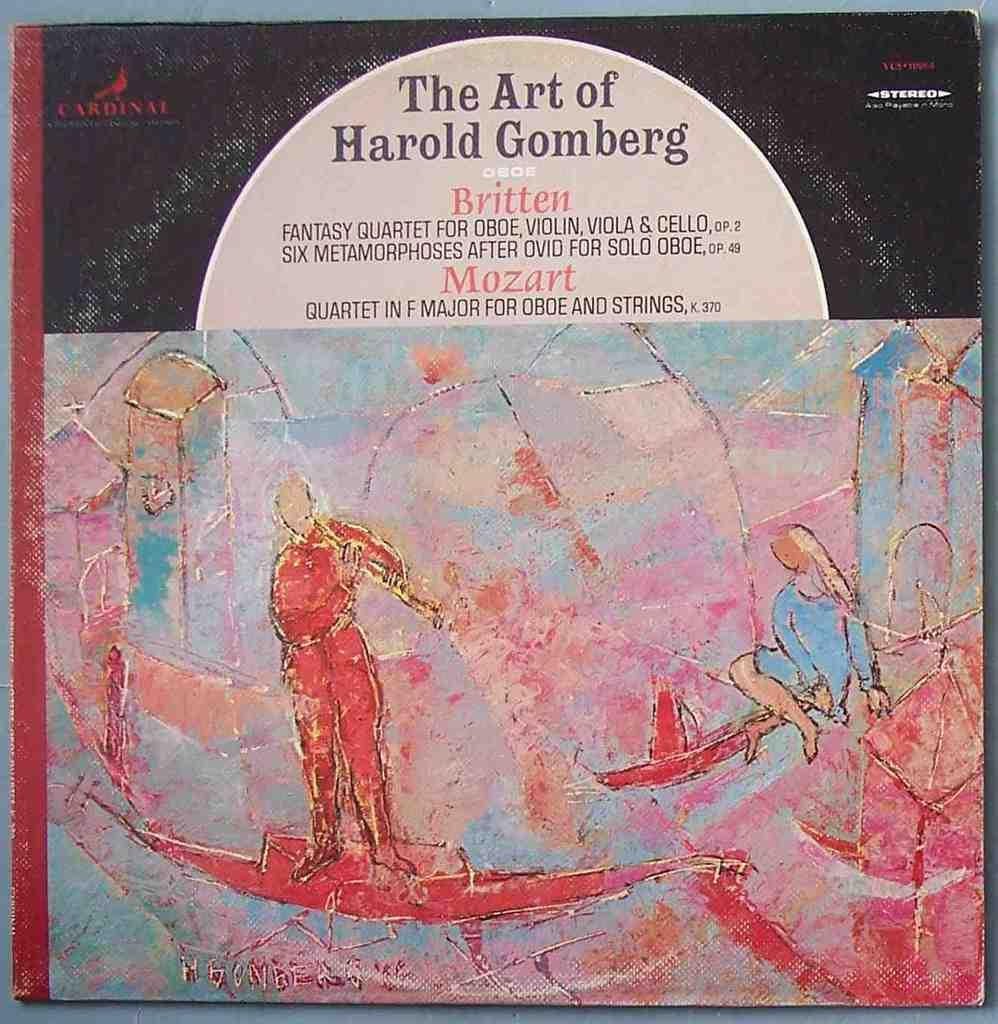<image>
Give a short and clear explanation of the subsequent image. A stereo recording includes works by Britten and Mozart. 